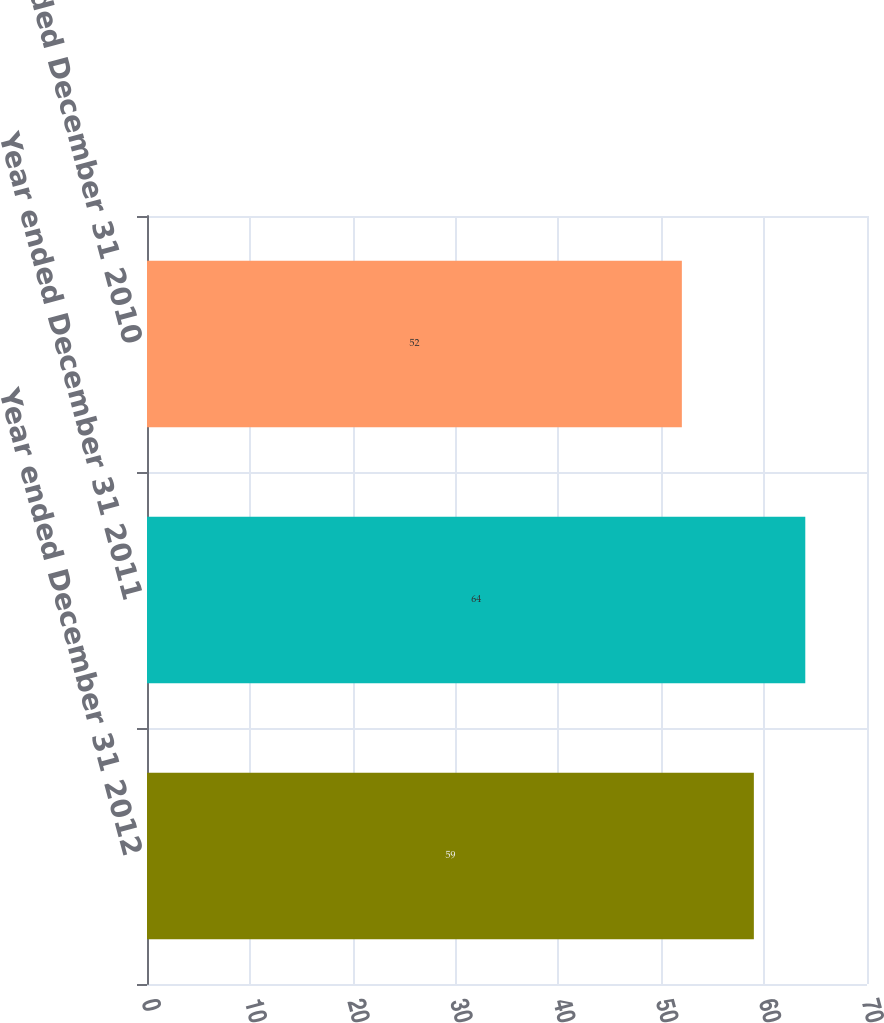Convert chart. <chart><loc_0><loc_0><loc_500><loc_500><bar_chart><fcel>Year ended December 31 2012<fcel>Year ended December 31 2011<fcel>Year ended December 31 2010<nl><fcel>59<fcel>64<fcel>52<nl></chart> 